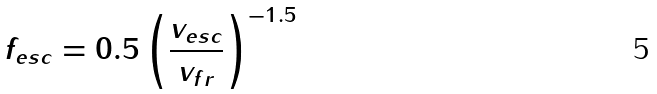Convert formula to latex. <formula><loc_0><loc_0><loc_500><loc_500>f _ { e s c } = 0 . 5 \left ( \frac { v _ { e s c } } { v _ { f r } } \right ) ^ { - 1 . 5 }</formula> 